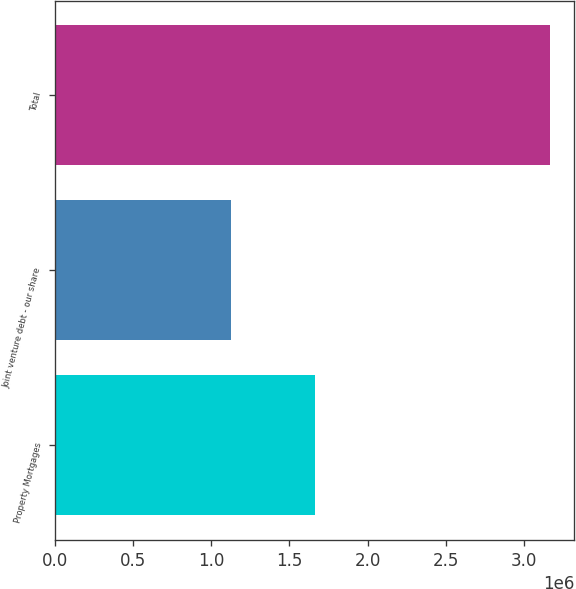Convert chart to OTSL. <chart><loc_0><loc_0><loc_500><loc_500><bar_chart><fcel>Property Mortgages<fcel>Joint venture debt - our share<fcel>Total<nl><fcel>1.66339e+06<fcel>1.1247e+06<fcel>3.16281e+06<nl></chart> 